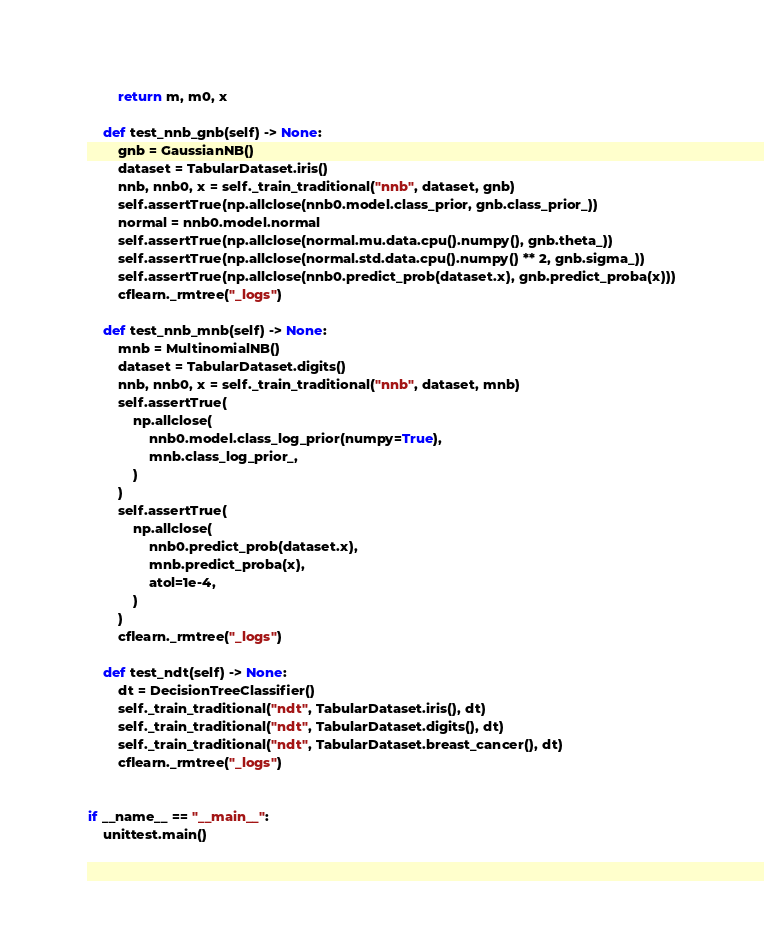Convert code to text. <code><loc_0><loc_0><loc_500><loc_500><_Python_>        return m, m0, x

    def test_nnb_gnb(self) -> None:
        gnb = GaussianNB()
        dataset = TabularDataset.iris()
        nnb, nnb0, x = self._train_traditional("nnb", dataset, gnb)
        self.assertTrue(np.allclose(nnb0.model.class_prior, gnb.class_prior_))
        normal = nnb0.model.normal
        self.assertTrue(np.allclose(normal.mu.data.cpu().numpy(), gnb.theta_))
        self.assertTrue(np.allclose(normal.std.data.cpu().numpy() ** 2, gnb.sigma_))
        self.assertTrue(np.allclose(nnb0.predict_prob(dataset.x), gnb.predict_proba(x)))
        cflearn._rmtree("_logs")

    def test_nnb_mnb(self) -> None:
        mnb = MultinomialNB()
        dataset = TabularDataset.digits()
        nnb, nnb0, x = self._train_traditional("nnb", dataset, mnb)
        self.assertTrue(
            np.allclose(
                nnb0.model.class_log_prior(numpy=True),
                mnb.class_log_prior_,
            )
        )
        self.assertTrue(
            np.allclose(
                nnb0.predict_prob(dataset.x),
                mnb.predict_proba(x),
                atol=1e-4,
            )
        )
        cflearn._rmtree("_logs")

    def test_ndt(self) -> None:
        dt = DecisionTreeClassifier()
        self._train_traditional("ndt", TabularDataset.iris(), dt)
        self._train_traditional("ndt", TabularDataset.digits(), dt)
        self._train_traditional("ndt", TabularDataset.breast_cancer(), dt)
        cflearn._rmtree("_logs")


if __name__ == "__main__":
    unittest.main()
</code> 